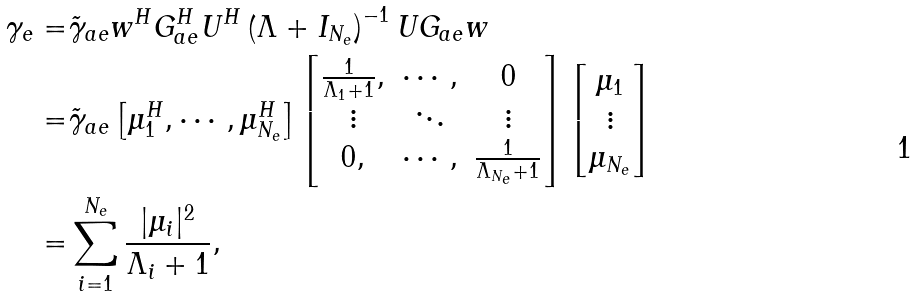Convert formula to latex. <formula><loc_0><loc_0><loc_500><loc_500>\gamma _ { e } = & \tilde { \gamma } _ { a e } w ^ { H } G _ { a e } ^ { H } U ^ { H } \left ( \Lambda + I _ { N _ { e } } \right ) ^ { - 1 } U G _ { a e } w \\ = & \tilde { \gamma } _ { a e } \begin{bmatrix} \mu _ { 1 } ^ { H } , \cdots , \mu _ { N _ { e } } ^ { H } \end{bmatrix} \begin{bmatrix} \frac { 1 } { \Lambda _ { 1 } + 1 } , & \cdots , & 0 \\ \vdots & \ddots & \vdots \\ 0 , & \cdots , & \frac { 1 } { \Lambda _ { N _ { e } } + 1 } \end{bmatrix} \begin{bmatrix} { \mu _ { 1 } } \\ \vdots \\ { \mu _ { N _ { e } } } \end{bmatrix} \\ = & \sum _ { i = 1 } ^ { N _ { e } } \frac { | \mu _ { i } | ^ { 2 } } { \Lambda _ { i } + 1 } ,</formula> 